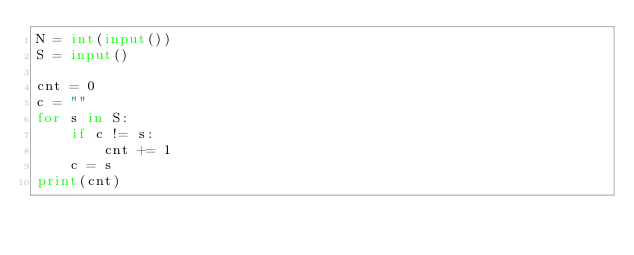<code> <loc_0><loc_0><loc_500><loc_500><_Python_>N = int(input())
S = input()

cnt = 0
c = ""
for s in S:
    if c != s:
        cnt += 1
    c = s
print(cnt)
</code> 